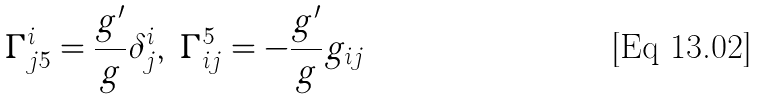<formula> <loc_0><loc_0><loc_500><loc_500>\Gamma ^ { i } _ { j 5 } = \frac { g ^ { \prime } } { g } \delta ^ { i } _ { j } , \ \Gamma _ { i j } ^ { 5 } = - \frac { g ^ { \prime } } { g } g _ { i j }</formula> 